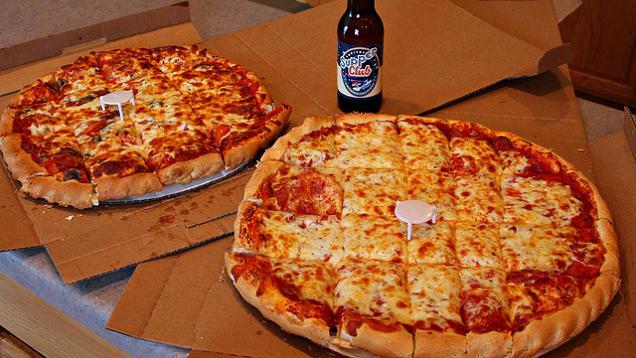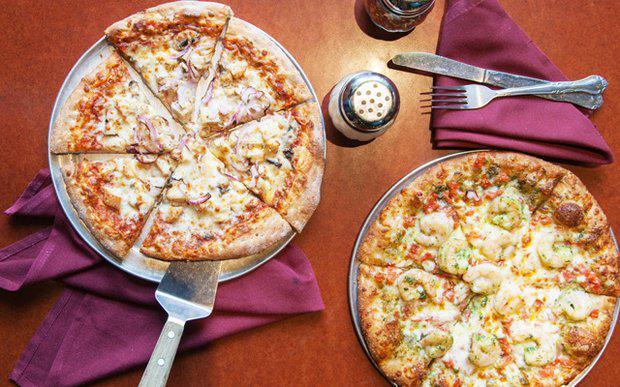The first image is the image on the left, the second image is the image on the right. Given the left and right images, does the statement "In the left image a slice is being lifted off the pizza." hold true? Answer yes or no. No. The first image is the image on the left, the second image is the image on the right. Analyze the images presented: Is the assertion "Four pizzas are visible." valid? Answer yes or no. Yes. 